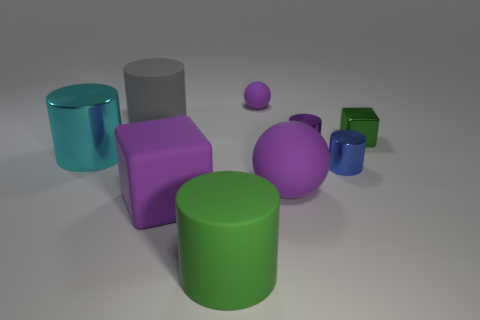Subtract all red cylinders. Subtract all purple blocks. How many cylinders are left? 5 Add 1 blue metal cylinders. How many objects exist? 10 Subtract all spheres. How many objects are left? 7 Add 6 large purple rubber things. How many large purple rubber things are left? 8 Add 5 tiny balls. How many tiny balls exist? 6 Subtract 0 brown balls. How many objects are left? 9 Subtract all green shiny objects. Subtract all green rubber objects. How many objects are left? 7 